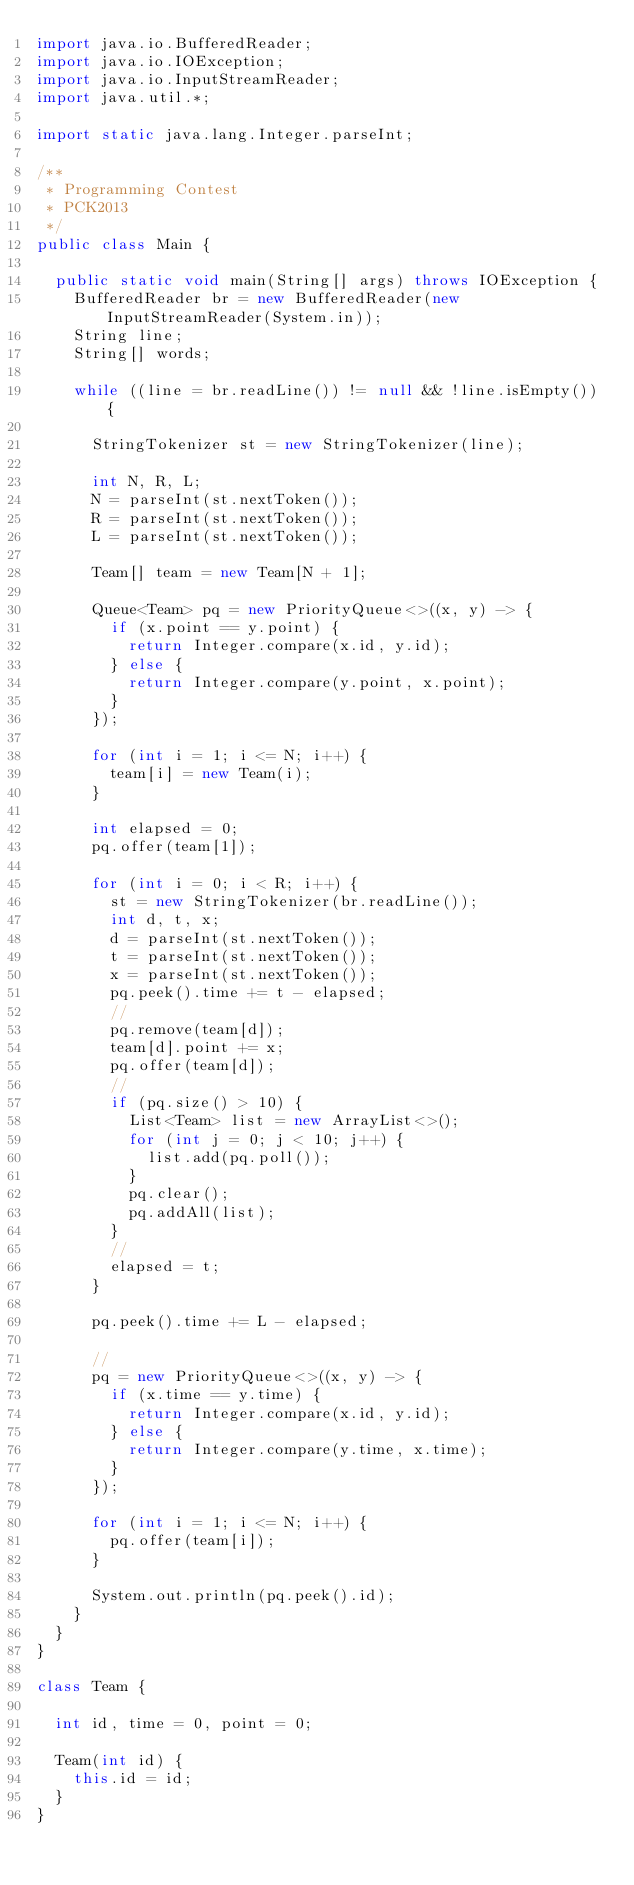Convert code to text. <code><loc_0><loc_0><loc_500><loc_500><_Java_>import java.io.BufferedReader;
import java.io.IOException;
import java.io.InputStreamReader;
import java.util.*;

import static java.lang.Integer.parseInt;

/**
 * Programming Contest
 * PCK2013
 */
public class Main {

	public static void main(String[] args) throws IOException {
		BufferedReader br = new BufferedReader(new InputStreamReader(System.in));
		String line;
		String[] words;

		while ((line = br.readLine()) != null && !line.isEmpty()) {

			StringTokenizer st = new StringTokenizer(line);

			int N, R, L;
			N = parseInt(st.nextToken());
			R = parseInt(st.nextToken());
			L = parseInt(st.nextToken());

			Team[] team = new Team[N + 1];

			Queue<Team> pq = new PriorityQueue<>((x, y) -> {
				if (x.point == y.point) {
					return Integer.compare(x.id, y.id);
				} else {
					return Integer.compare(y.point, x.point);
				}
			});

			for (int i = 1; i <= N; i++) {
				team[i] = new Team(i);
			}

			int elapsed = 0;
			pq.offer(team[1]);

			for (int i = 0; i < R; i++) {
				st = new StringTokenizer(br.readLine());
				int d, t, x;
				d = parseInt(st.nextToken());
				t = parseInt(st.nextToken());
				x = parseInt(st.nextToken());
				pq.peek().time += t - elapsed;
				//
				pq.remove(team[d]);
				team[d].point += x;
				pq.offer(team[d]);
				//
				if (pq.size() > 10) {
					List<Team> list = new ArrayList<>();
					for (int j = 0; j < 10; j++) {
						list.add(pq.poll());
					}
					pq.clear();
					pq.addAll(list);
				}
				//
				elapsed = t;
			}

			pq.peek().time += L - elapsed;

			//
			pq = new PriorityQueue<>((x, y) -> {
				if (x.time == y.time) {
					return Integer.compare(x.id, y.id);
				} else {
					return Integer.compare(y.time, x.time);
				}
			});

			for (int i = 1; i <= N; i++) {
				pq.offer(team[i]);
			}

			System.out.println(pq.peek().id);
		}
	}
}

class Team {

	int id, time = 0, point = 0;

	Team(int id) {
		this.id = id;
	}
}</code> 